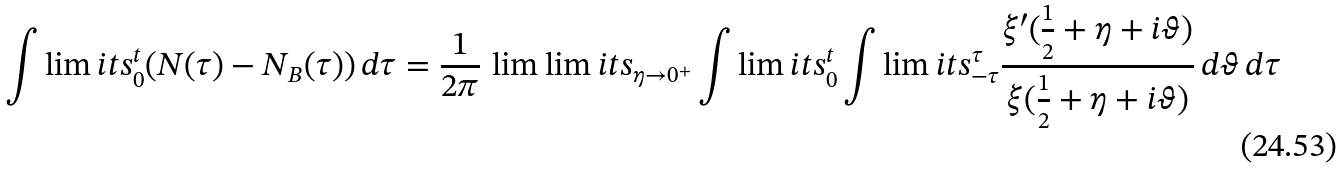Convert formula to latex. <formula><loc_0><loc_0><loc_500><loc_500>\int \lim i t s _ { 0 } ^ { t } ( N ( \tau ) - N _ { B } ( \tau ) ) \, d \tau = \frac { 1 } { 2 \pi } \, \lim \lim i t s _ { \eta \to 0 ^ { + } } \int \lim i t s _ { 0 } ^ { t } \int \lim i t s _ { - \tau } ^ { \tau } \frac { \xi ^ { \prime } ( \frac { 1 } { 2 } + \eta + i \vartheta ) } { \xi ( \frac { 1 } { 2 } + \eta + i \vartheta ) } \, d \vartheta \, d \tau</formula> 